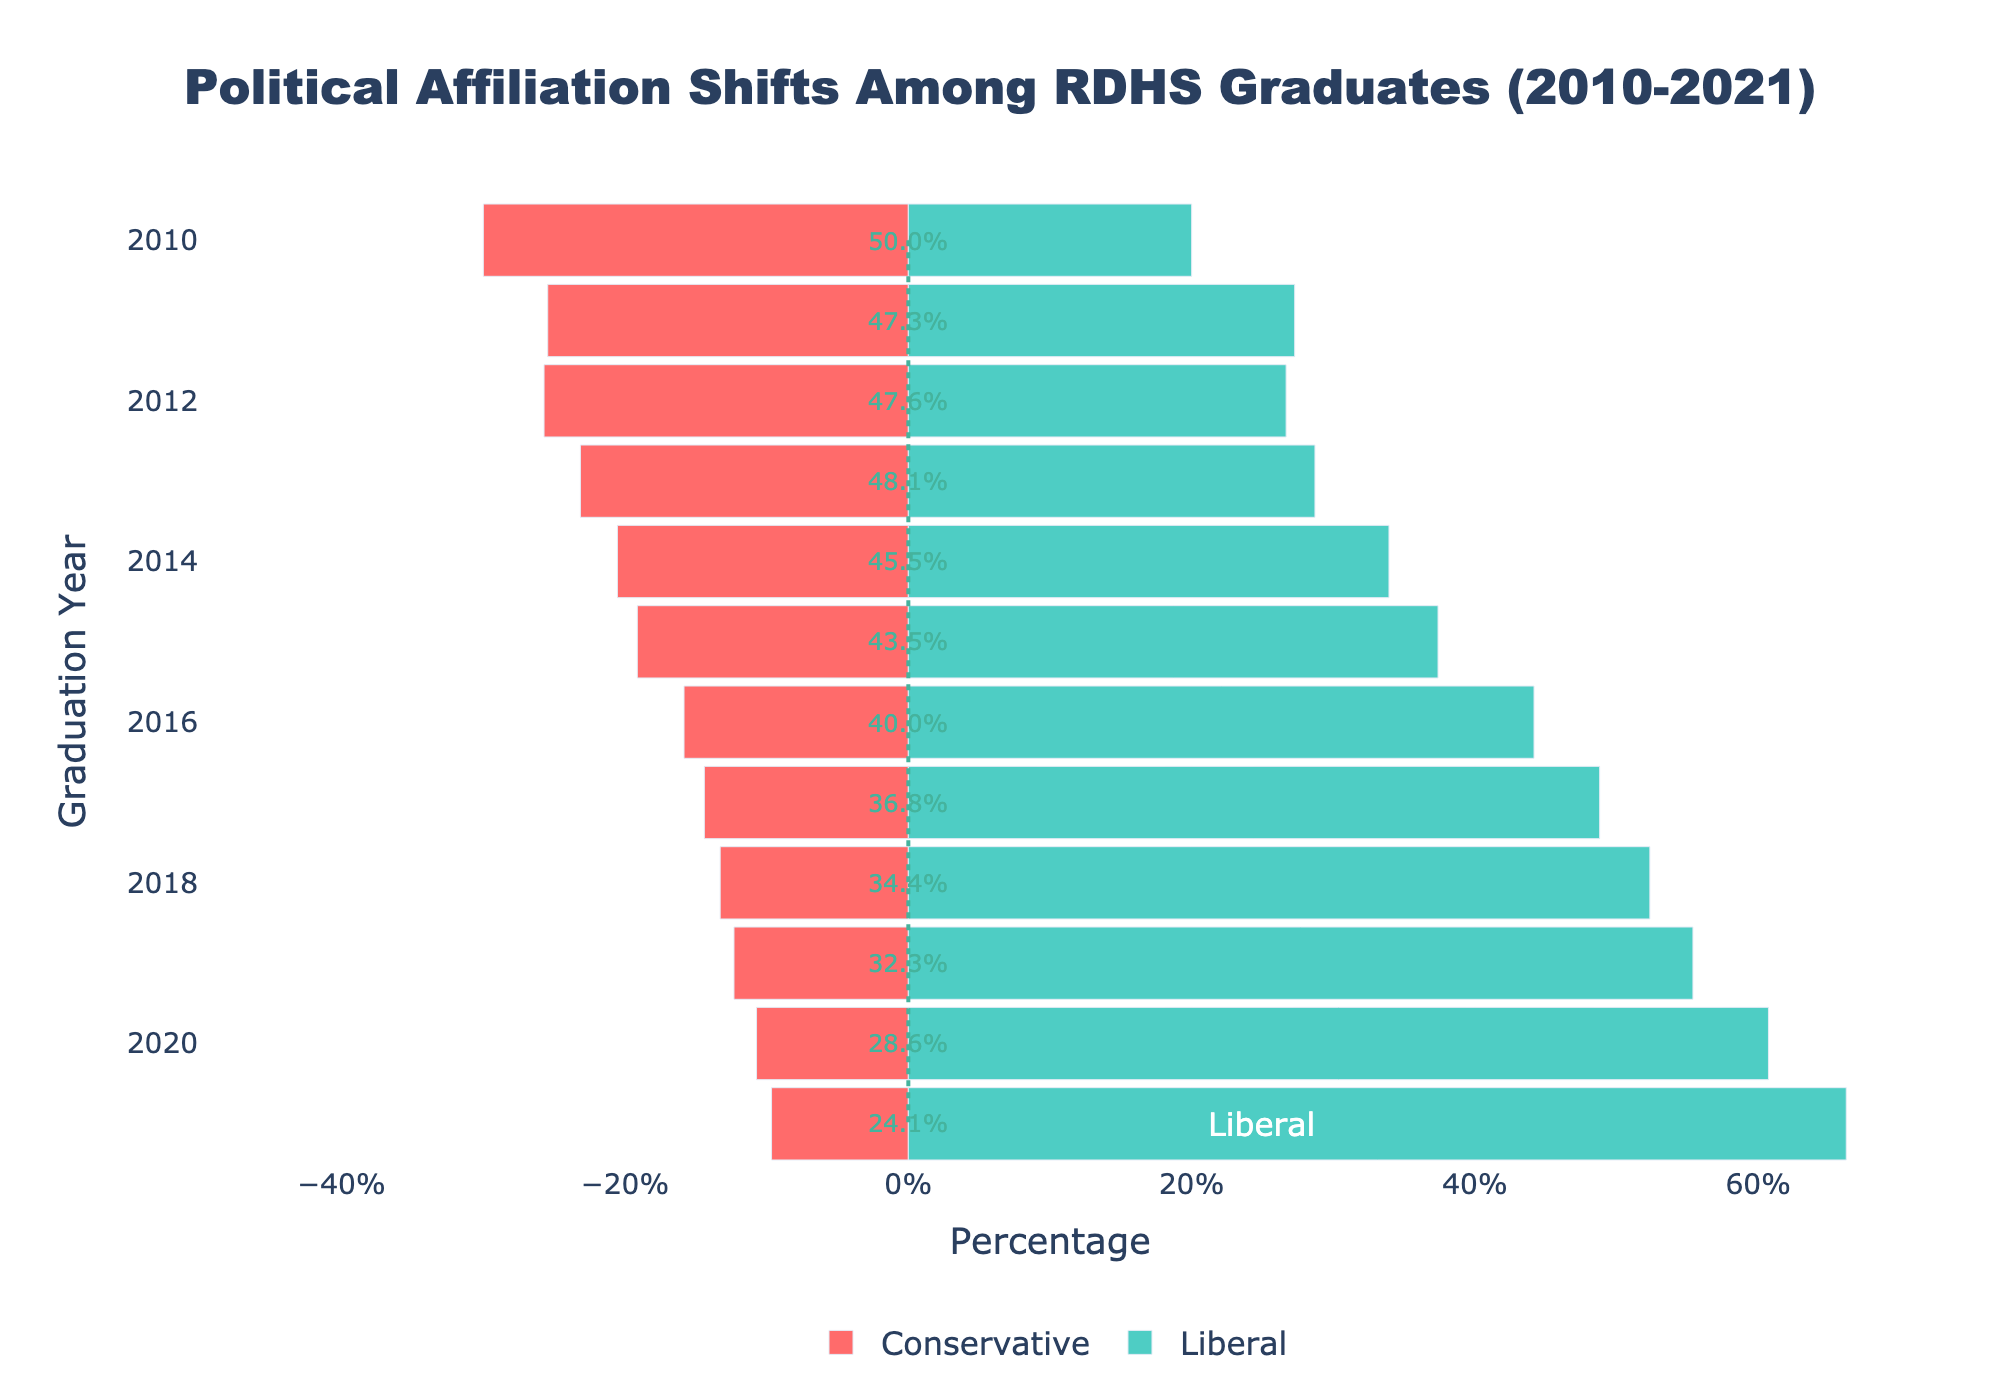What's the trend in the percentage of graduates identifying as conservative from 2010 to 2021? To find the trend, observe the red bars representing conservatives across the years from 2010 to 2021. The bars steadily decrease in length, indicating a declining trend in the percentage of conservative graduates.
Answer: Declining Which political affiliation has shown the most significant increase over time? Look at the change in the length of the bars from 2010 to 2021 for both conservative (red) and liberal (green). The liberal group's bars have significantly increased in length, indicating the most significant increase over time.
Answer: Liberal In which year did the percentage of liberal-leaning graduates first surpass 50%? To determine this, locate the first year where the green bar exceeds 50%. This occurs in 2016.
Answer: 2016 What percentage of graduates identified as moderates in 2016? Refer to the annotation for the moderate percentage in 2016, depicted as a percentage value next to the center line.
Answer: 48% Compare the percentage of liberal versus conservative graduates in 2021. In 2021, the green bar representing liberals extends to approximately 66%, while the red bar representing conservatives extends to about -10%. The liberals (66%) far exceed the conservatives (-10%).
Answer: Liberal > Conservative What is the overall trend for the moderate affiliation from 2010 to 2021? Review the annotations for the moderate percentages across the years from 2010 to 2021. The percentages generally decrease, indicating a decline in moderate affiliation.
Answer: Decreasing Which year had the highest percentage of conservative graduates? Identify the longest red bar. In 2010, the conservative percentage was the highest.
Answer: 2010 Calculate the approximate average percentage of graduates identifying as liberals from 2010 to 2021. Sum the percentages of liberals over the years and then divide by the number of years. (20 + 30 + 28 + 31 + 38 + 43 + 53 + 61 + 67 + 72 + 85 + 96) / 12 = approximately 50.3%
Answer: 50.3% How much has the percentage of conservative graduates dropped from 2010 to 2021? The conservative percentage in 2010 was 30%, and in 2021 it was 10%. The drop is 30% - 10% = 20%.
Answer: 20% What is the visual difference between the percentage of moderate and liberal graduates in 2019? In 2019, the annotation for moderates indicates about 42%, and the green bar for liberals extends to 72%. The difference, depicted visually and calculated as 72% - 42%, is 30%.
Answer: 30% 